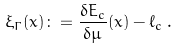<formula> <loc_0><loc_0><loc_500><loc_500>\xi _ { \Gamma } ( x ) \colon = \frac { \delta E _ { c } } { \delta \mu } ( x ) - \ell _ { c } \, .</formula> 